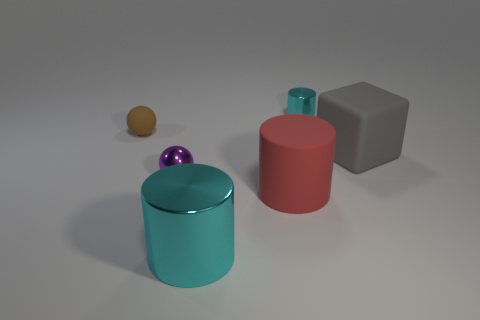Add 3 brown matte balls. How many objects exist? 9 Subtract all blocks. How many objects are left? 5 Add 5 small brown metallic things. How many small brown metallic things exist? 5 Subtract 1 gray blocks. How many objects are left? 5 Subtract all brown balls. Subtract all red cylinders. How many objects are left? 4 Add 1 cyan metal cylinders. How many cyan metal cylinders are left? 3 